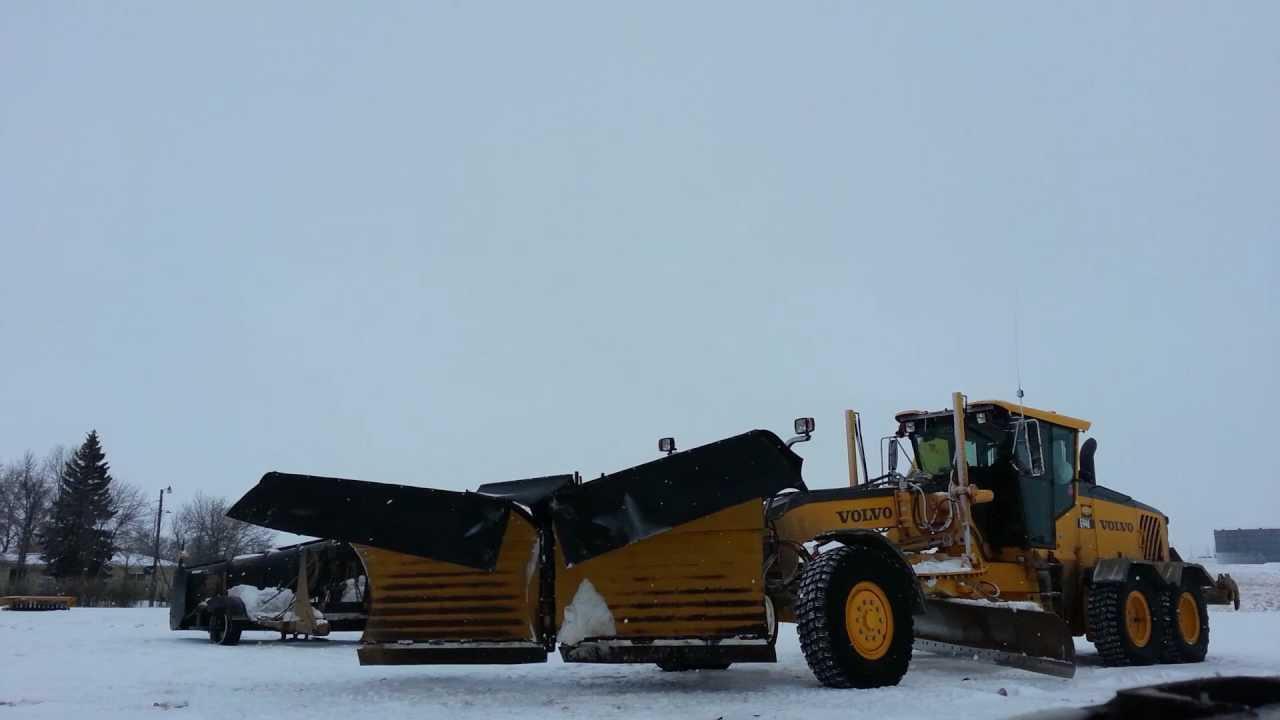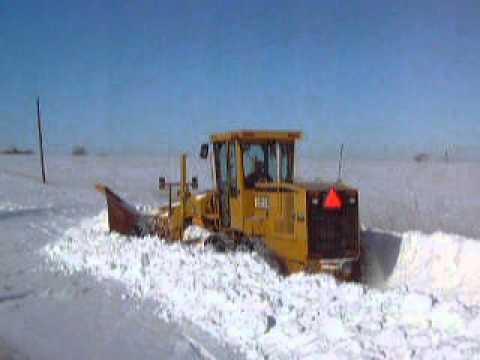The first image is the image on the left, the second image is the image on the right. Analyze the images presented: Is the assertion "The lights in the image on the left are mounted on a handlebar shaped mount." valid? Answer yes or no. No. The first image is the image on the left, the second image is the image on the right. Evaluate the accuracy of this statement regarding the images: "Right image shows at least one yellow tractor with plow on a dirt ground without snow.". Is it true? Answer yes or no. No. 